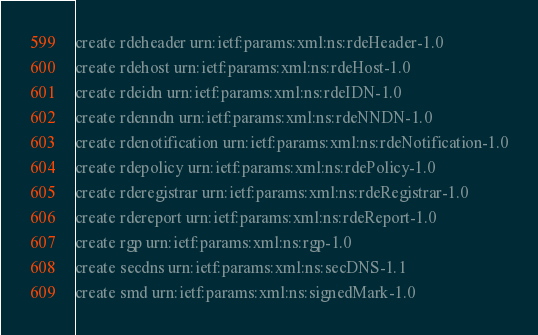<code> <loc_0><loc_0><loc_500><loc_500><_Bash_>create rdeheader urn:ietf:params:xml:ns:rdeHeader-1.0
create rdehost urn:ietf:params:xml:ns:rdeHost-1.0
create rdeidn urn:ietf:params:xml:ns:rdeIDN-1.0
create rdenndn urn:ietf:params:xml:ns:rdeNNDN-1.0
create rdenotification urn:ietf:params:xml:ns:rdeNotification-1.0
create rdepolicy urn:ietf:params:xml:ns:rdePolicy-1.0
create rderegistrar urn:ietf:params:xml:ns:rdeRegistrar-1.0
create rdereport urn:ietf:params:xml:ns:rdeReport-1.0
create rgp urn:ietf:params:xml:ns:rgp-1.0
create secdns urn:ietf:params:xml:ns:secDNS-1.1
create smd urn:ietf:params:xml:ns:signedMark-1.0
</code> 